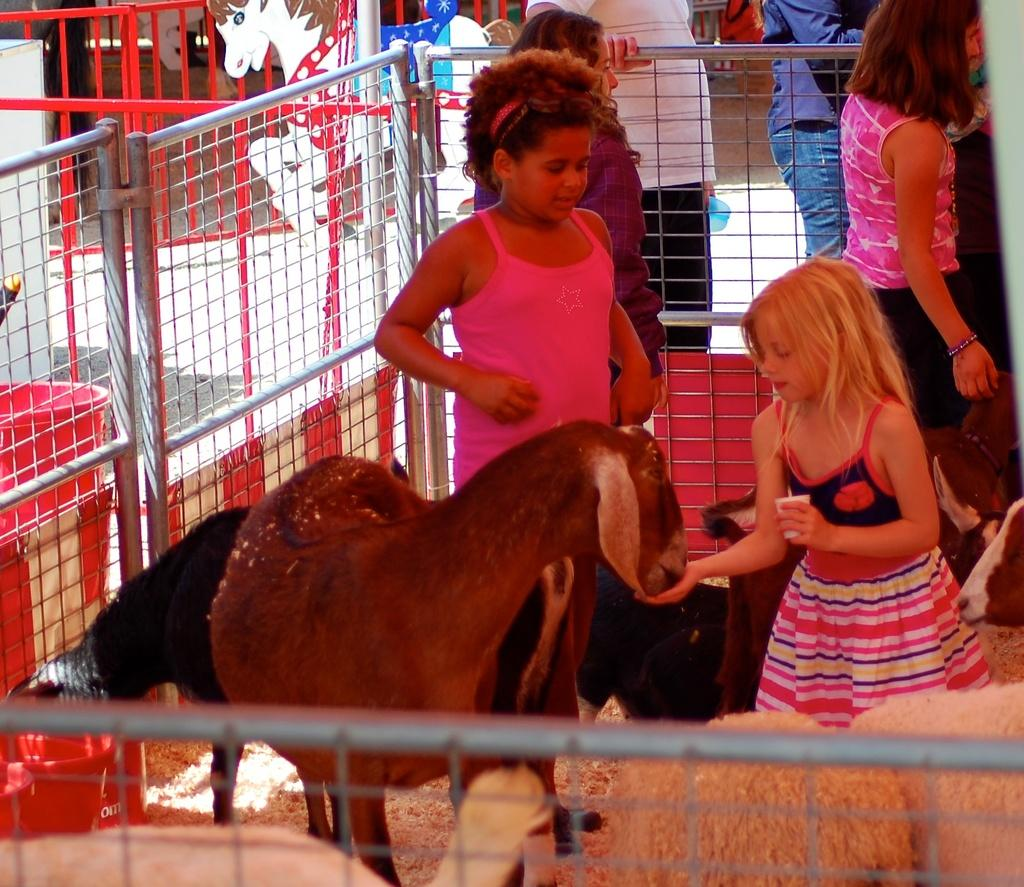What animals are present in the image? There are goats and sheep in the image. What is the girl in the image doing? The girl is feeding a goat with her hand. Are there any other people in the image besides the girl? Yes, there are people standing in the image. What can be seen in the background of the image? There is a metal fence in the image. What type of land can be seen in the image? There is no specific type of land mentioned or visible in the image. Can you hear the voice of the girl in the image? The image is a still picture, so there is no sound or voice present. 